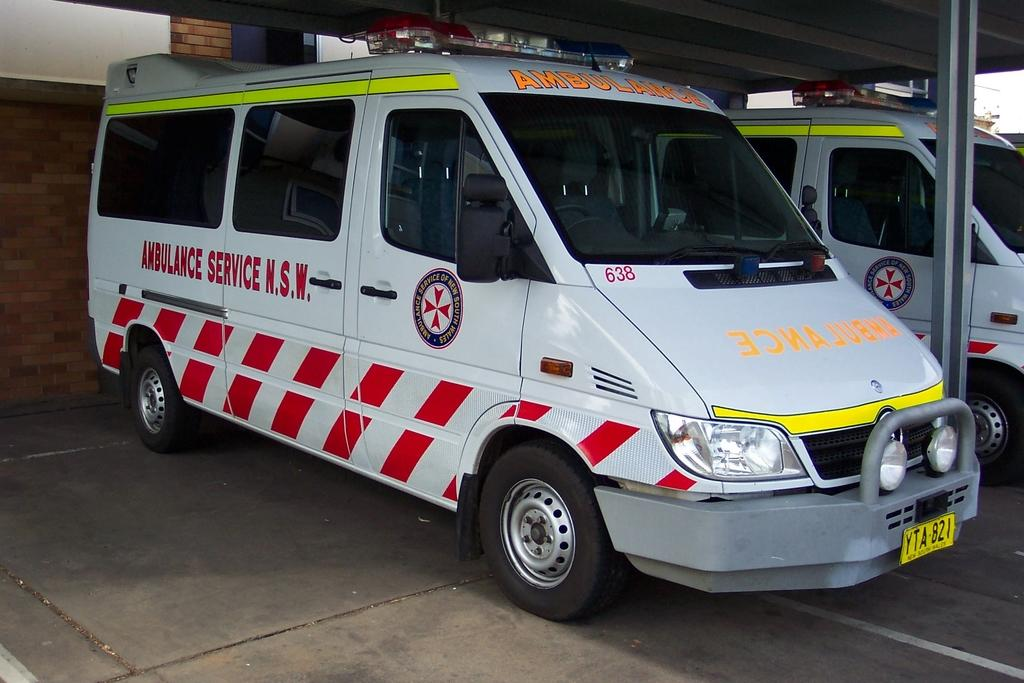<image>
Give a short and clear explanation of the subsequent image. A white van with, "Ambulance Services N.S.W is parked under a roof. 